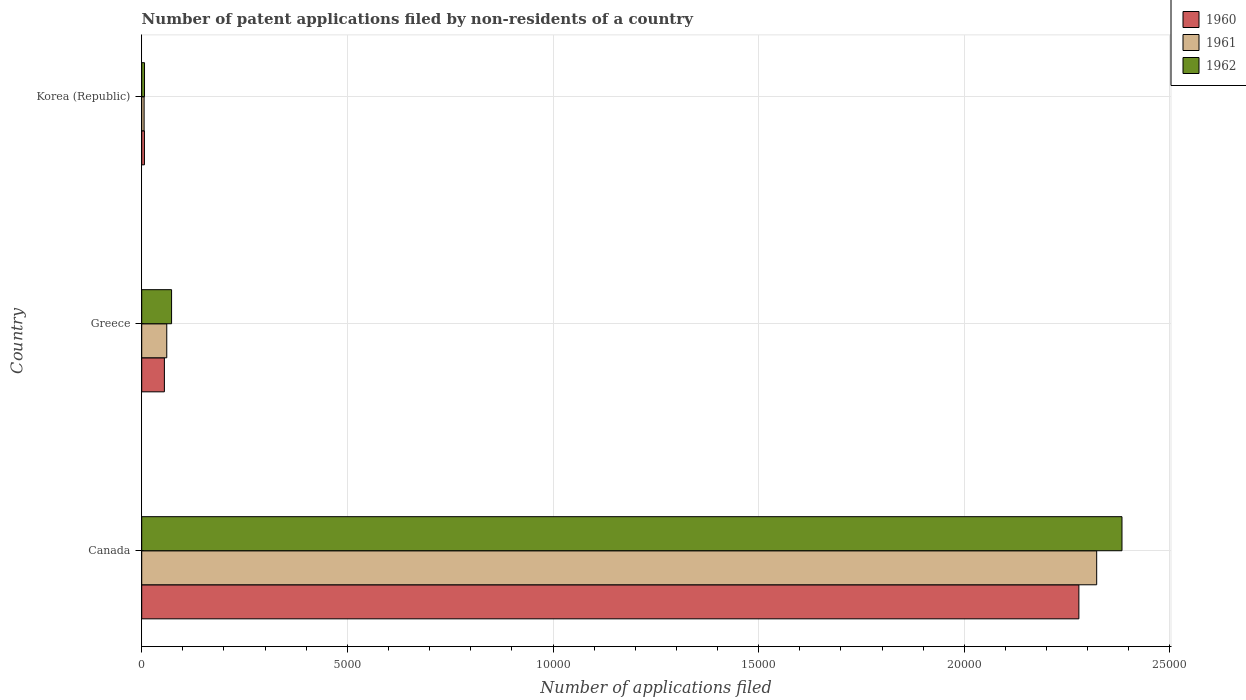How many different coloured bars are there?
Offer a terse response. 3. How many groups of bars are there?
Your response must be concise. 3. What is the label of the 3rd group of bars from the top?
Your answer should be very brief. Canada. What is the number of applications filed in 1960 in Greece?
Make the answer very short. 551. Across all countries, what is the maximum number of applications filed in 1962?
Your answer should be compact. 2.38e+04. Across all countries, what is the minimum number of applications filed in 1960?
Provide a short and direct response. 66. In which country was the number of applications filed in 1962 minimum?
Give a very brief answer. Korea (Republic). What is the total number of applications filed in 1960 in the graph?
Your response must be concise. 2.34e+04. What is the difference between the number of applications filed in 1962 in Canada and that in Korea (Republic)?
Offer a terse response. 2.38e+04. What is the difference between the number of applications filed in 1961 in Greece and the number of applications filed in 1962 in Canada?
Your answer should be compact. -2.32e+04. What is the average number of applications filed in 1961 per country?
Provide a short and direct response. 7962. What is the difference between the number of applications filed in 1962 and number of applications filed in 1961 in Canada?
Ensure brevity in your answer.  615. Is the difference between the number of applications filed in 1962 in Greece and Korea (Republic) greater than the difference between the number of applications filed in 1961 in Greece and Korea (Republic)?
Keep it short and to the point. Yes. What is the difference between the highest and the second highest number of applications filed in 1961?
Make the answer very short. 2.26e+04. What is the difference between the highest and the lowest number of applications filed in 1961?
Your answer should be compact. 2.32e+04. In how many countries, is the number of applications filed in 1960 greater than the average number of applications filed in 1960 taken over all countries?
Your answer should be very brief. 1. Is the sum of the number of applications filed in 1962 in Canada and Greece greater than the maximum number of applications filed in 1960 across all countries?
Offer a terse response. Yes. What does the 3rd bar from the top in Canada represents?
Offer a terse response. 1960. Is it the case that in every country, the sum of the number of applications filed in 1961 and number of applications filed in 1962 is greater than the number of applications filed in 1960?
Offer a terse response. Yes. How many countries are there in the graph?
Offer a very short reply. 3. What is the difference between two consecutive major ticks on the X-axis?
Your response must be concise. 5000. Does the graph contain any zero values?
Offer a very short reply. No. Does the graph contain grids?
Your answer should be very brief. Yes. How many legend labels are there?
Provide a succinct answer. 3. What is the title of the graph?
Provide a short and direct response. Number of patent applications filed by non-residents of a country. Does "1984" appear as one of the legend labels in the graph?
Your answer should be compact. No. What is the label or title of the X-axis?
Your answer should be compact. Number of applications filed. What is the label or title of the Y-axis?
Your answer should be compact. Country. What is the Number of applications filed in 1960 in Canada?
Your answer should be very brief. 2.28e+04. What is the Number of applications filed of 1961 in Canada?
Make the answer very short. 2.32e+04. What is the Number of applications filed of 1962 in Canada?
Keep it short and to the point. 2.38e+04. What is the Number of applications filed of 1960 in Greece?
Provide a short and direct response. 551. What is the Number of applications filed in 1961 in Greece?
Give a very brief answer. 609. What is the Number of applications filed of 1962 in Greece?
Provide a succinct answer. 726. What is the Number of applications filed in 1960 in Korea (Republic)?
Ensure brevity in your answer.  66. What is the Number of applications filed of 1961 in Korea (Republic)?
Keep it short and to the point. 58. Across all countries, what is the maximum Number of applications filed of 1960?
Your response must be concise. 2.28e+04. Across all countries, what is the maximum Number of applications filed of 1961?
Offer a terse response. 2.32e+04. Across all countries, what is the maximum Number of applications filed of 1962?
Keep it short and to the point. 2.38e+04. Across all countries, what is the minimum Number of applications filed of 1960?
Your answer should be very brief. 66. Across all countries, what is the minimum Number of applications filed in 1962?
Your answer should be very brief. 68. What is the total Number of applications filed of 1960 in the graph?
Your answer should be compact. 2.34e+04. What is the total Number of applications filed of 1961 in the graph?
Keep it short and to the point. 2.39e+04. What is the total Number of applications filed in 1962 in the graph?
Provide a short and direct response. 2.46e+04. What is the difference between the Number of applications filed of 1960 in Canada and that in Greece?
Offer a terse response. 2.22e+04. What is the difference between the Number of applications filed in 1961 in Canada and that in Greece?
Your answer should be compact. 2.26e+04. What is the difference between the Number of applications filed in 1962 in Canada and that in Greece?
Provide a short and direct response. 2.31e+04. What is the difference between the Number of applications filed of 1960 in Canada and that in Korea (Republic)?
Make the answer very short. 2.27e+04. What is the difference between the Number of applications filed of 1961 in Canada and that in Korea (Republic)?
Make the answer very short. 2.32e+04. What is the difference between the Number of applications filed of 1962 in Canada and that in Korea (Republic)?
Offer a terse response. 2.38e+04. What is the difference between the Number of applications filed of 1960 in Greece and that in Korea (Republic)?
Offer a terse response. 485. What is the difference between the Number of applications filed in 1961 in Greece and that in Korea (Republic)?
Provide a short and direct response. 551. What is the difference between the Number of applications filed of 1962 in Greece and that in Korea (Republic)?
Ensure brevity in your answer.  658. What is the difference between the Number of applications filed in 1960 in Canada and the Number of applications filed in 1961 in Greece?
Keep it short and to the point. 2.22e+04. What is the difference between the Number of applications filed in 1960 in Canada and the Number of applications filed in 1962 in Greece?
Ensure brevity in your answer.  2.21e+04. What is the difference between the Number of applications filed in 1961 in Canada and the Number of applications filed in 1962 in Greece?
Offer a terse response. 2.25e+04. What is the difference between the Number of applications filed of 1960 in Canada and the Number of applications filed of 1961 in Korea (Republic)?
Your answer should be very brief. 2.27e+04. What is the difference between the Number of applications filed in 1960 in Canada and the Number of applications filed in 1962 in Korea (Republic)?
Your answer should be compact. 2.27e+04. What is the difference between the Number of applications filed of 1961 in Canada and the Number of applications filed of 1962 in Korea (Republic)?
Offer a very short reply. 2.32e+04. What is the difference between the Number of applications filed of 1960 in Greece and the Number of applications filed of 1961 in Korea (Republic)?
Make the answer very short. 493. What is the difference between the Number of applications filed of 1960 in Greece and the Number of applications filed of 1962 in Korea (Republic)?
Offer a terse response. 483. What is the difference between the Number of applications filed of 1961 in Greece and the Number of applications filed of 1962 in Korea (Republic)?
Your answer should be very brief. 541. What is the average Number of applications filed in 1960 per country?
Offer a terse response. 7801. What is the average Number of applications filed of 1961 per country?
Your answer should be compact. 7962. What is the average Number of applications filed of 1962 per country?
Offer a terse response. 8209.33. What is the difference between the Number of applications filed of 1960 and Number of applications filed of 1961 in Canada?
Keep it short and to the point. -433. What is the difference between the Number of applications filed of 1960 and Number of applications filed of 1962 in Canada?
Your response must be concise. -1048. What is the difference between the Number of applications filed of 1961 and Number of applications filed of 1962 in Canada?
Ensure brevity in your answer.  -615. What is the difference between the Number of applications filed of 1960 and Number of applications filed of 1961 in Greece?
Give a very brief answer. -58. What is the difference between the Number of applications filed in 1960 and Number of applications filed in 1962 in Greece?
Your response must be concise. -175. What is the difference between the Number of applications filed of 1961 and Number of applications filed of 1962 in Greece?
Offer a very short reply. -117. What is the difference between the Number of applications filed of 1960 and Number of applications filed of 1961 in Korea (Republic)?
Your response must be concise. 8. What is the difference between the Number of applications filed in 1961 and Number of applications filed in 1962 in Korea (Republic)?
Provide a succinct answer. -10. What is the ratio of the Number of applications filed of 1960 in Canada to that in Greece?
Provide a succinct answer. 41.35. What is the ratio of the Number of applications filed in 1961 in Canada to that in Greece?
Make the answer very short. 38.13. What is the ratio of the Number of applications filed in 1962 in Canada to that in Greece?
Make the answer very short. 32.83. What is the ratio of the Number of applications filed of 1960 in Canada to that in Korea (Republic)?
Make the answer very short. 345.24. What is the ratio of the Number of applications filed of 1961 in Canada to that in Korea (Republic)?
Offer a terse response. 400.33. What is the ratio of the Number of applications filed in 1962 in Canada to that in Korea (Republic)?
Give a very brief answer. 350.5. What is the ratio of the Number of applications filed of 1960 in Greece to that in Korea (Republic)?
Provide a succinct answer. 8.35. What is the ratio of the Number of applications filed in 1962 in Greece to that in Korea (Republic)?
Your answer should be very brief. 10.68. What is the difference between the highest and the second highest Number of applications filed of 1960?
Make the answer very short. 2.22e+04. What is the difference between the highest and the second highest Number of applications filed in 1961?
Offer a terse response. 2.26e+04. What is the difference between the highest and the second highest Number of applications filed in 1962?
Your answer should be compact. 2.31e+04. What is the difference between the highest and the lowest Number of applications filed of 1960?
Offer a terse response. 2.27e+04. What is the difference between the highest and the lowest Number of applications filed of 1961?
Your response must be concise. 2.32e+04. What is the difference between the highest and the lowest Number of applications filed in 1962?
Keep it short and to the point. 2.38e+04. 